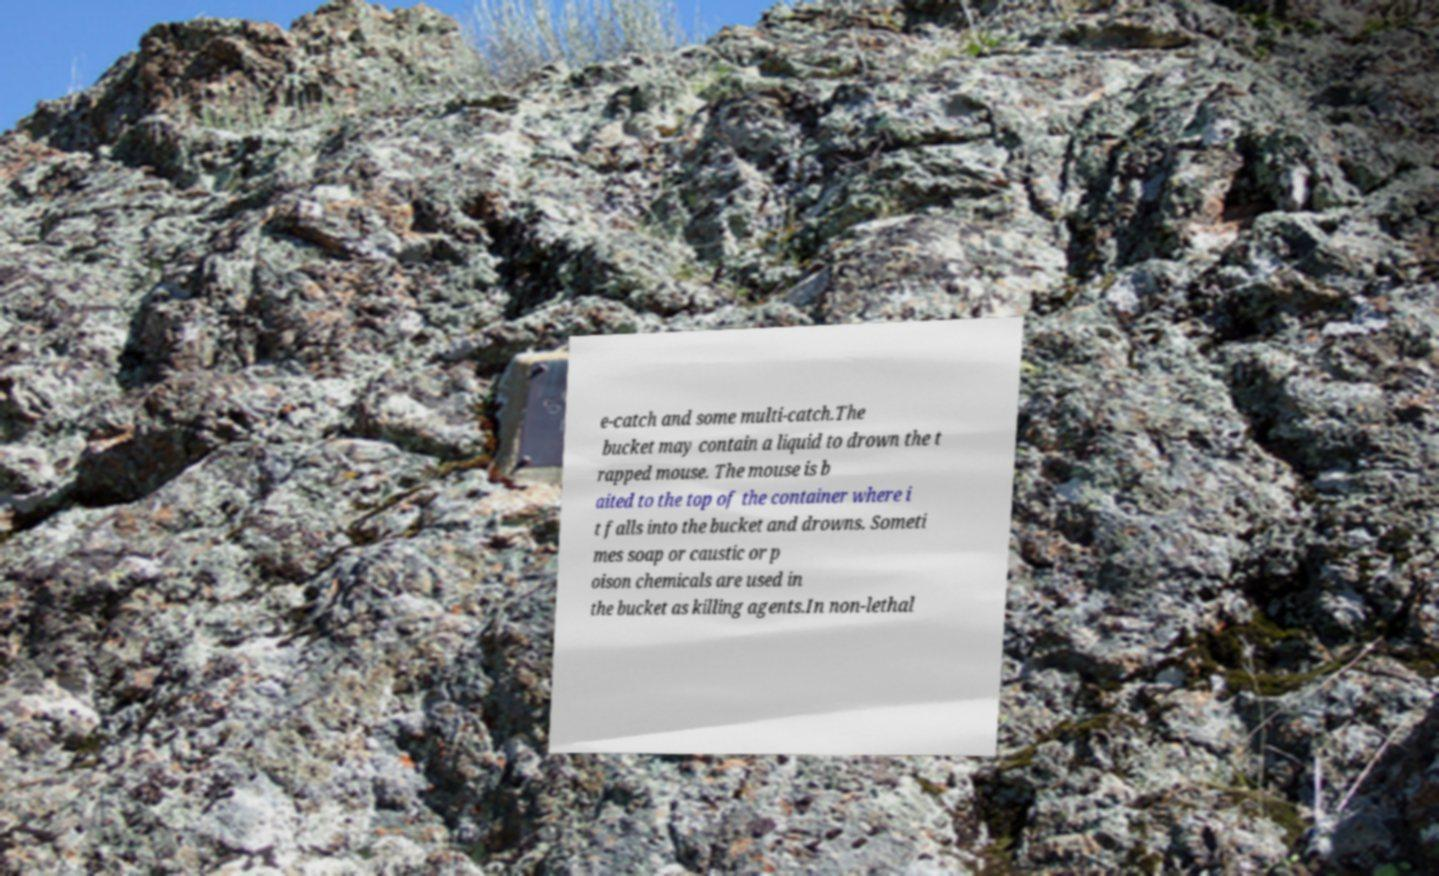Can you read and provide the text displayed in the image?This photo seems to have some interesting text. Can you extract and type it out for me? e-catch and some multi-catch.The bucket may contain a liquid to drown the t rapped mouse. The mouse is b aited to the top of the container where i t falls into the bucket and drowns. Someti mes soap or caustic or p oison chemicals are used in the bucket as killing agents.In non-lethal 